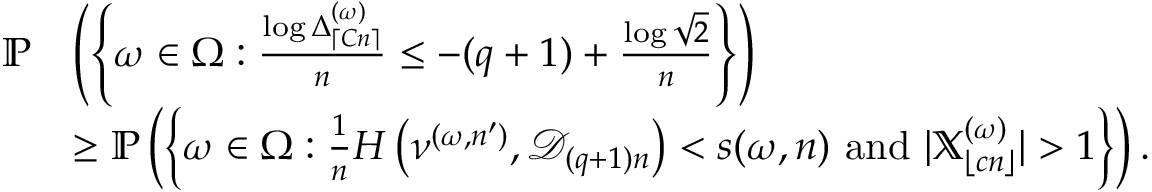Convert formula to latex. <formula><loc_0><loc_0><loc_500><loc_500>\begin{array} { r l } { \mathbb { P } } & { \left ( \left \{ \omega \in \Omega \colon \frac { \log \Delta _ { \lceil C n \rceil } ^ { ( \omega ) } } { n } \leq - ( q + 1 ) + \frac { \log \sqrt { 2 } } { n } \right \} \right ) } \\ & { \geq \mathbb { P } \left ( \left \{ \omega \in \Omega \colon \frac { 1 } { n } H \left ( \nu ^ { ( \omega , n ^ { \prime } ) } , { \mathcal { D } } _ { ( q + 1 ) n } \right ) < s ( \omega , n ) a n d | \mathbb { X } _ { \lfloor c n \rfloor } ^ { ( \omega ) } | > 1 \right \} \right ) . } \end{array}</formula> 